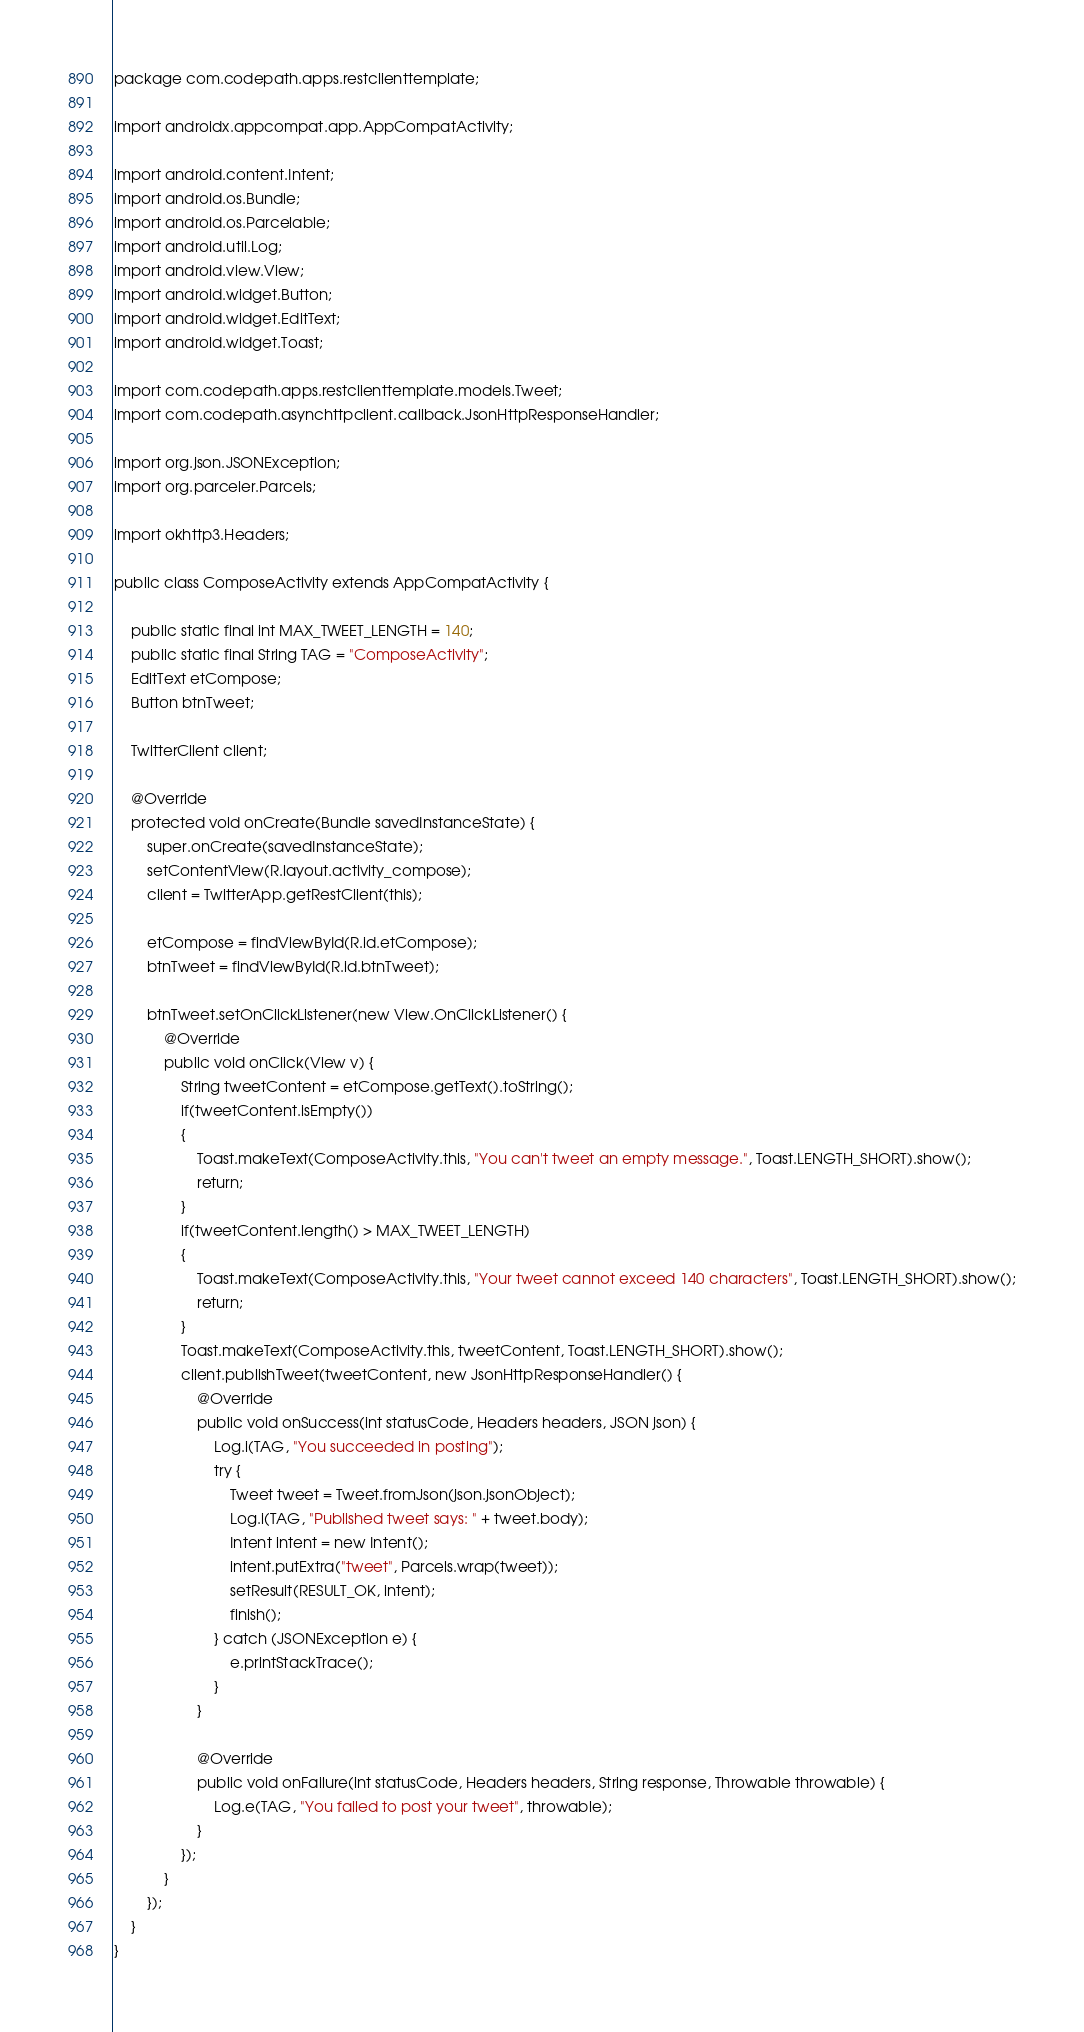Convert code to text. <code><loc_0><loc_0><loc_500><loc_500><_Java_>package com.codepath.apps.restclienttemplate;

import androidx.appcompat.app.AppCompatActivity;

import android.content.Intent;
import android.os.Bundle;
import android.os.Parcelable;
import android.util.Log;
import android.view.View;
import android.widget.Button;
import android.widget.EditText;
import android.widget.Toast;

import com.codepath.apps.restclienttemplate.models.Tweet;
import com.codepath.asynchttpclient.callback.JsonHttpResponseHandler;

import org.json.JSONException;
import org.parceler.Parcels;

import okhttp3.Headers;

public class ComposeActivity extends AppCompatActivity {

    public static final int MAX_TWEET_LENGTH = 140;
    public static final String TAG = "ComposeActivity";
    EditText etCompose;
    Button btnTweet;

    TwitterClient client;

    @Override
    protected void onCreate(Bundle savedInstanceState) {
        super.onCreate(savedInstanceState);
        setContentView(R.layout.activity_compose);
        client = TwitterApp.getRestClient(this);

        etCompose = findViewById(R.id.etCompose);
        btnTweet = findViewById(R.id.btnTweet);

        btnTweet.setOnClickListener(new View.OnClickListener() {
            @Override
            public void onClick(View v) {
                String tweetContent = etCompose.getText().toString();
                if(tweetContent.isEmpty())
                {
                    Toast.makeText(ComposeActivity.this, "You can't tweet an empty message.", Toast.LENGTH_SHORT).show();
                    return;
                }
                if(tweetContent.length() > MAX_TWEET_LENGTH)
                {
                    Toast.makeText(ComposeActivity.this, "Your tweet cannot exceed 140 characters", Toast.LENGTH_SHORT).show();
                    return;
                }
                Toast.makeText(ComposeActivity.this, tweetContent, Toast.LENGTH_SHORT).show();
                client.publishTweet(tweetContent, new JsonHttpResponseHandler() {
                    @Override
                    public void onSuccess(int statusCode, Headers headers, JSON json) {
                        Log.i(TAG, "You succeeded in posting");
                        try {
                            Tweet tweet = Tweet.fromJson(json.jsonObject);
                            Log.i(TAG, "Published tweet says: " + tweet.body);
                            Intent intent = new Intent();
                            intent.putExtra("tweet", Parcels.wrap(tweet));
                            setResult(RESULT_OK, intent);
                            finish();
                        } catch (JSONException e) {
                            e.printStackTrace();
                        }
                    }

                    @Override
                    public void onFailure(int statusCode, Headers headers, String response, Throwable throwable) {
                        Log.e(TAG, "You failed to post your tweet", throwable);
                    }
                });
            }
        });
    }
}</code> 